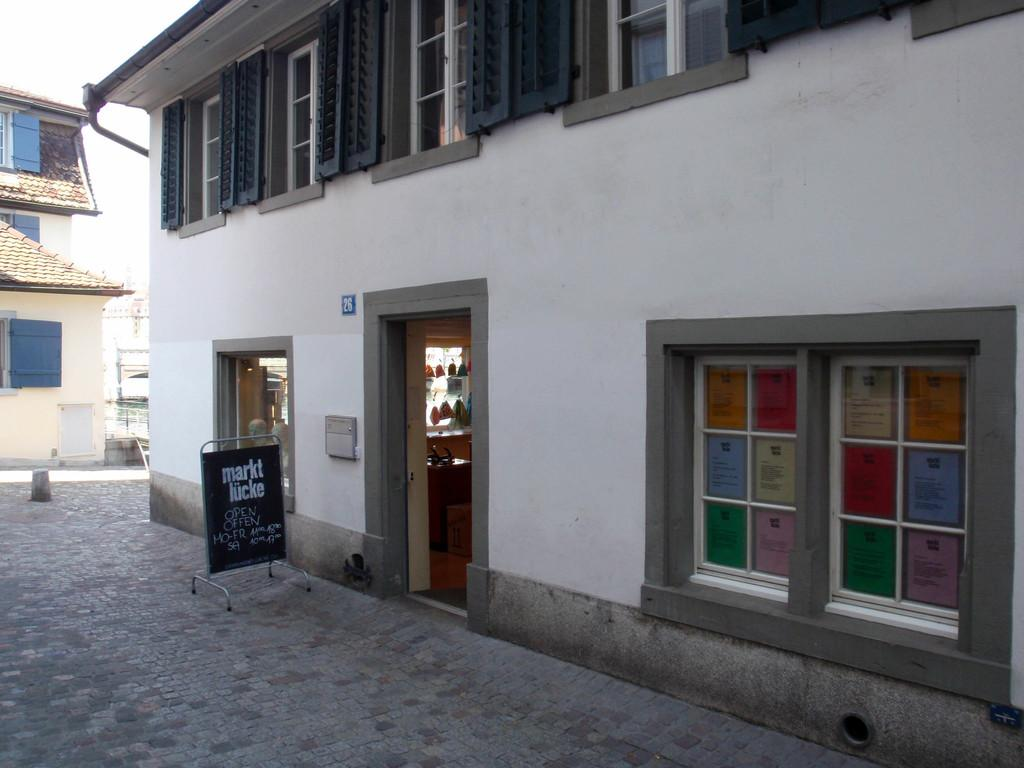What type of structures are visible in the image? There are buildings in the image. What feature do the buildings have? The buildings have windows. What else can be seen in the image besides the buildings? There are boards present in the image. Can you tell me how many times the mind swings back and forth in the image? There is no mention of a mind or any swinging motion in the image; it features buildings with windows and boards. 